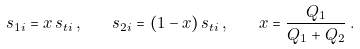Convert formula to latex. <formula><loc_0><loc_0><loc_500><loc_500>s _ { 1 i } = x \, s _ { t i } \, , \quad s _ { 2 i } = ( 1 - x ) \, s _ { t i } \, , \quad x = \frac { Q _ { 1 } } { Q _ { 1 } + Q _ { 2 } } \, .</formula> 